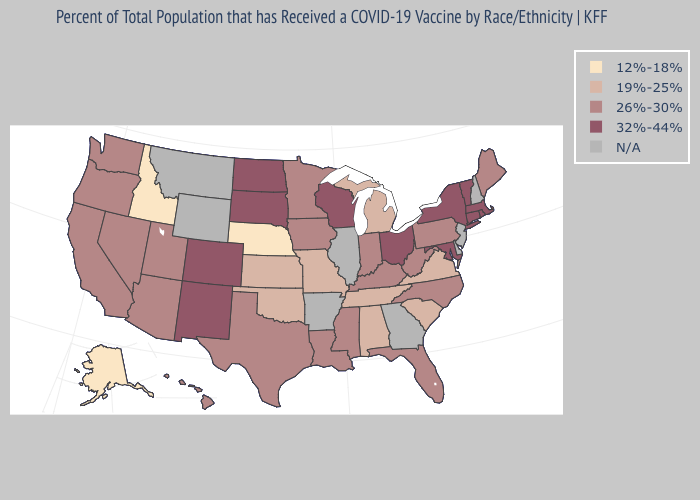Is the legend a continuous bar?
Answer briefly. No. Name the states that have a value in the range N/A?
Concise answer only. Arkansas, Delaware, Georgia, Illinois, Montana, New Hampshire, New Jersey, Wyoming. What is the value of Indiana?
Short answer required. 26%-30%. What is the value of California?
Be succinct. 26%-30%. What is the highest value in states that border Utah?
Keep it brief. 32%-44%. Name the states that have a value in the range 26%-30%?
Quick response, please. Arizona, California, Florida, Hawaii, Indiana, Iowa, Kentucky, Louisiana, Maine, Minnesota, Mississippi, Nevada, North Carolina, Oregon, Pennsylvania, Texas, Utah, Washington, West Virginia. What is the value of Idaho?
Write a very short answer. 12%-18%. Which states have the highest value in the USA?
Be succinct. Colorado, Connecticut, Maryland, Massachusetts, New Mexico, New York, North Dakota, Ohio, Rhode Island, South Dakota, Vermont, Wisconsin. Name the states that have a value in the range 12%-18%?
Keep it brief. Alaska, Idaho, Nebraska. Among the states that border New Hampshire , which have the lowest value?
Quick response, please. Maine. What is the value of Utah?
Short answer required. 26%-30%. Name the states that have a value in the range N/A?
Keep it brief. Arkansas, Delaware, Georgia, Illinois, Montana, New Hampshire, New Jersey, Wyoming. Name the states that have a value in the range 12%-18%?
Be succinct. Alaska, Idaho, Nebraska. What is the lowest value in states that border Texas?
Answer briefly. 19%-25%. Does Maine have the highest value in the Northeast?
Be succinct. No. 